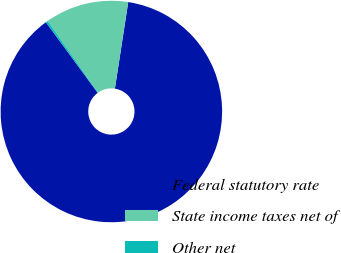Convert chart. <chart><loc_0><loc_0><loc_500><loc_500><pie_chart><fcel>Federal statutory rate<fcel>State income taxes net of<fcel>Other net<nl><fcel>87.5%<fcel>12.19%<fcel>0.31%<nl></chart> 